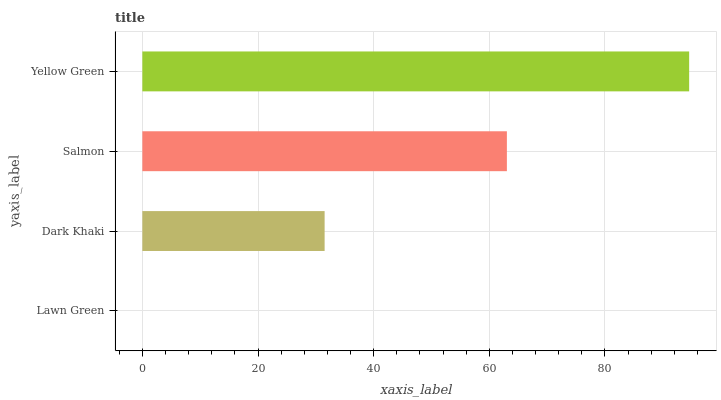Is Lawn Green the minimum?
Answer yes or no. Yes. Is Yellow Green the maximum?
Answer yes or no. Yes. Is Dark Khaki the minimum?
Answer yes or no. No. Is Dark Khaki the maximum?
Answer yes or no. No. Is Dark Khaki greater than Lawn Green?
Answer yes or no. Yes. Is Lawn Green less than Dark Khaki?
Answer yes or no. Yes. Is Lawn Green greater than Dark Khaki?
Answer yes or no. No. Is Dark Khaki less than Lawn Green?
Answer yes or no. No. Is Salmon the high median?
Answer yes or no. Yes. Is Dark Khaki the low median?
Answer yes or no. Yes. Is Dark Khaki the high median?
Answer yes or no. No. Is Yellow Green the low median?
Answer yes or no. No. 